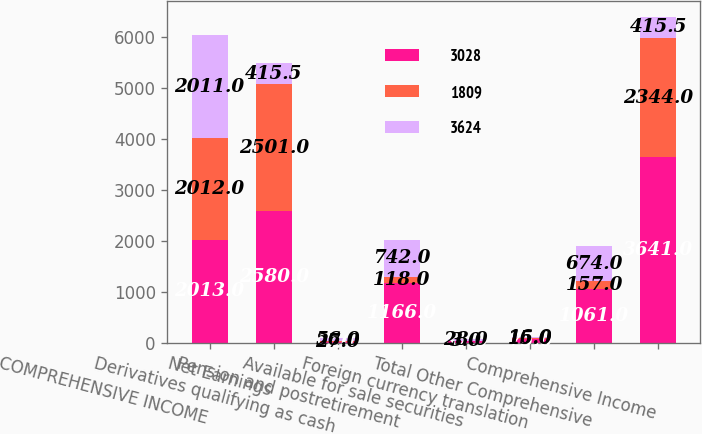<chart> <loc_0><loc_0><loc_500><loc_500><stacked_bar_chart><ecel><fcel>COMPREHENSIVE INCOME<fcel>Net Earnings<fcel>Derivatives qualifying as cash<fcel>Pension and postretirement<fcel>Available for sale securities<fcel>Foreign currency translation<fcel>Total Other Comprehensive<fcel>Comprehensive Income<nl><fcel>3028<fcel>2013<fcel>2580<fcel>7<fcel>1166<fcel>37<fcel>75<fcel>1061<fcel>3641<nl><fcel>1809<fcel>2012<fcel>2501<fcel>27<fcel>118<fcel>3<fcel>15<fcel>157<fcel>2344<nl><fcel>3624<fcel>2011<fcel>415.5<fcel>56<fcel>742<fcel>28<fcel>16<fcel>674<fcel>415.5<nl></chart> 